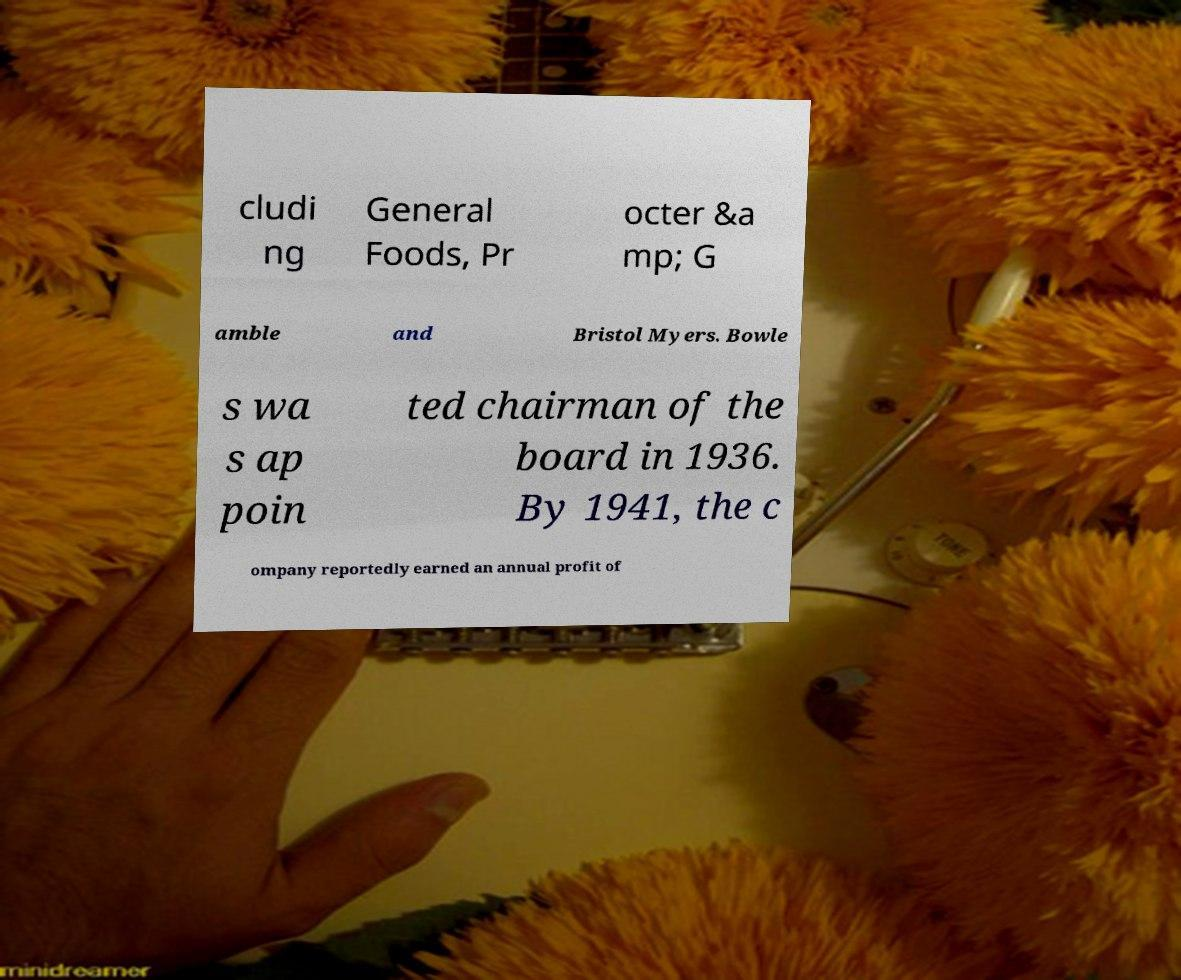What messages or text are displayed in this image? I need them in a readable, typed format. cludi ng General Foods, Pr octer &a mp; G amble and Bristol Myers. Bowle s wa s ap poin ted chairman of the board in 1936. By 1941, the c ompany reportedly earned an annual profit of 